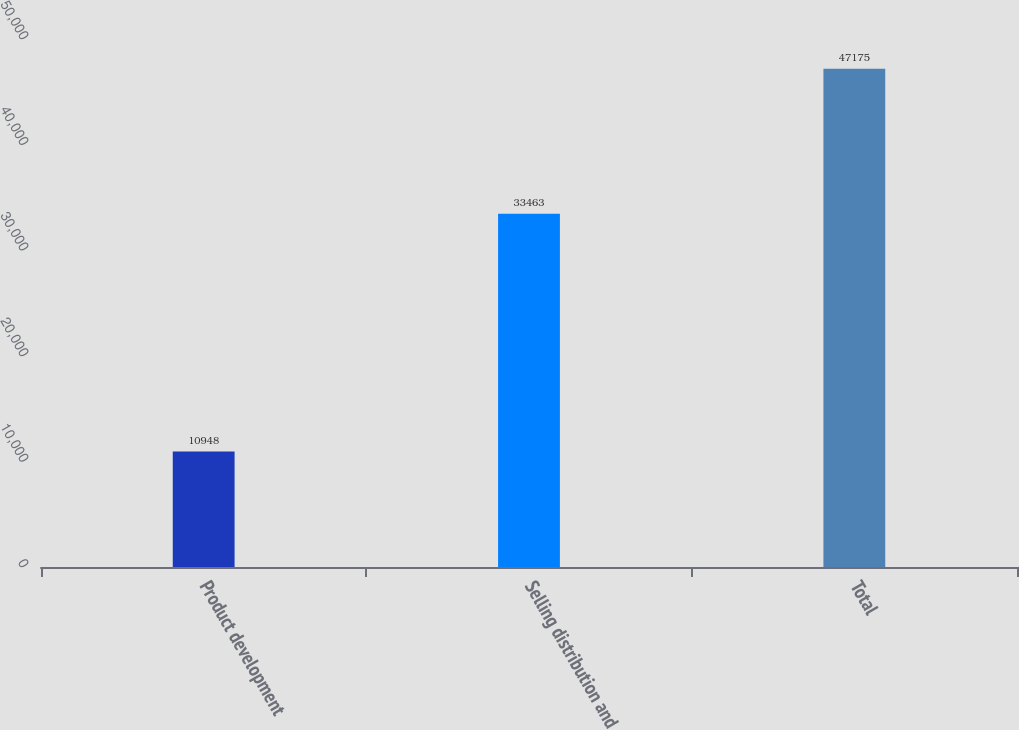Convert chart to OTSL. <chart><loc_0><loc_0><loc_500><loc_500><bar_chart><fcel>Product development<fcel>Selling distribution and<fcel>Total<nl><fcel>10948<fcel>33463<fcel>47175<nl></chart> 